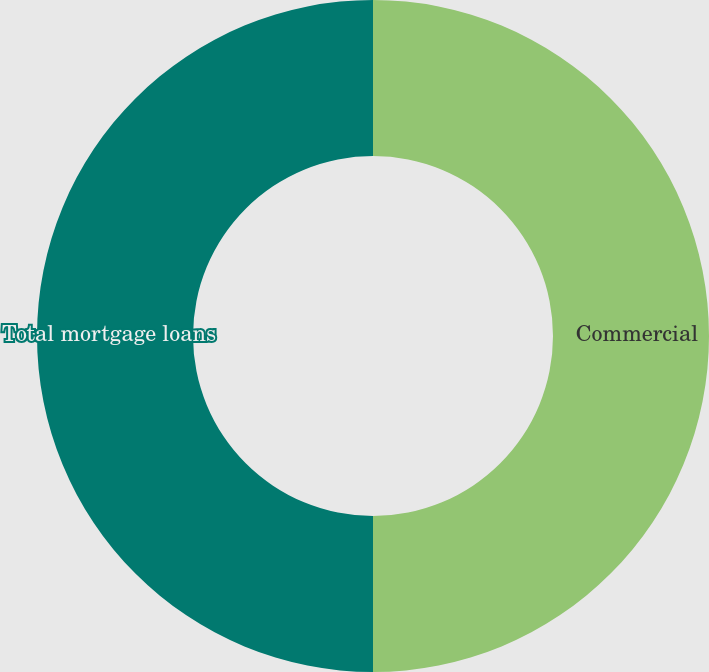Convert chart to OTSL. <chart><loc_0><loc_0><loc_500><loc_500><pie_chart><fcel>Commercial<fcel>Total mortgage loans<nl><fcel>50.0%<fcel>50.0%<nl></chart> 